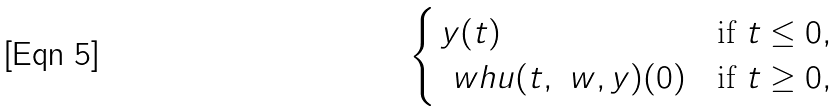Convert formula to latex. <formula><loc_0><loc_0><loc_500><loc_500>\begin{cases} \, y ( t ) & \text {if } t \leq 0 , \\ \, \ w h u ( t , \ w , y ) ( 0 ) & \text {if } t \geq 0 , \end{cases}</formula> 